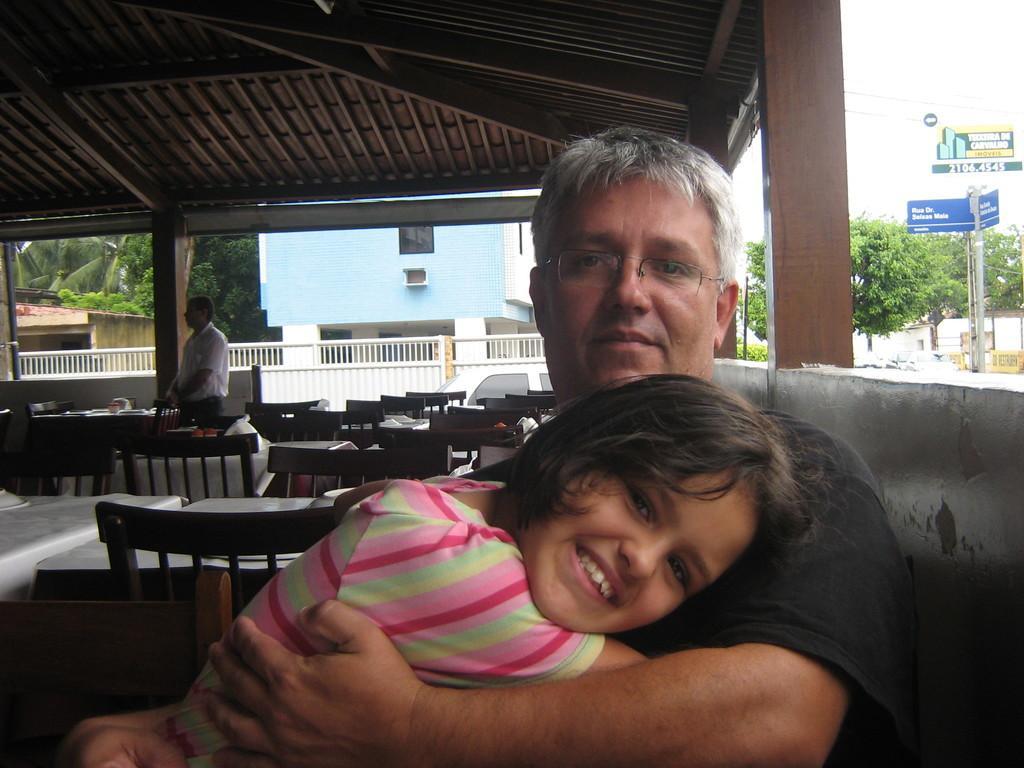How would you summarize this image in a sentence or two? Man in black t-shirt is holding a girl with his hands. Beside him, we see many tables and chairs. I think this picture might be clicked in a restaurant and behind that, we see iron railing and blue building. Beside that, we see many trees. In the right corner of the picture, we see a pole and a board which is blue in color. 